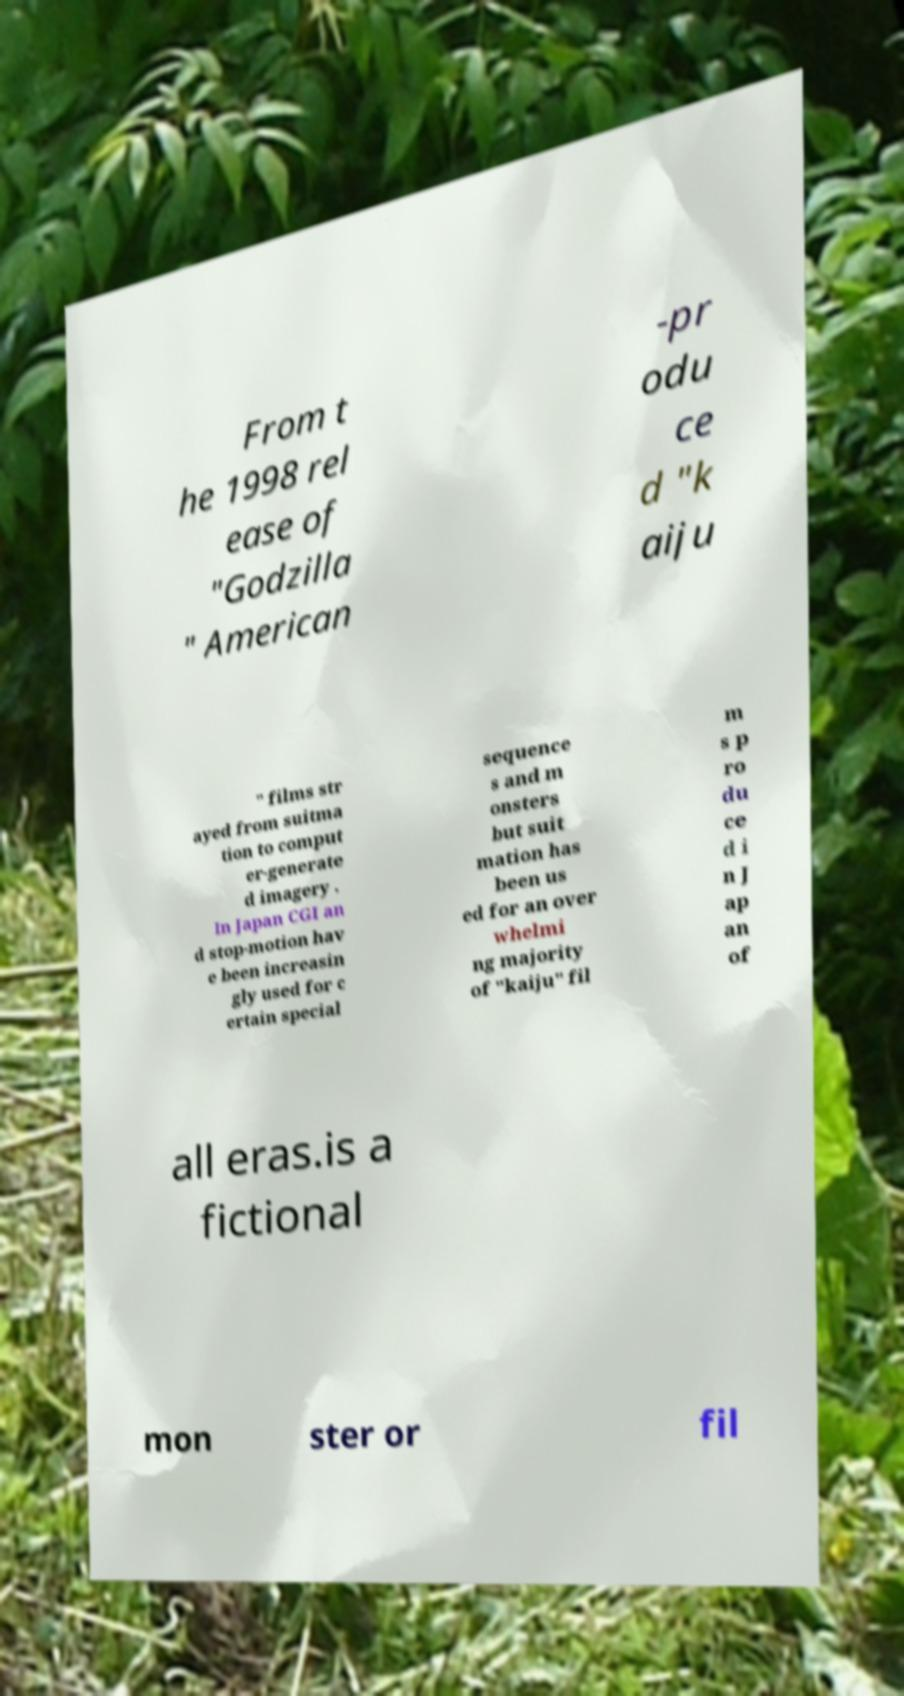Can you read and provide the text displayed in the image?This photo seems to have some interesting text. Can you extract and type it out for me? From t he 1998 rel ease of "Godzilla " American -pr odu ce d "k aiju " films str ayed from suitma tion to comput er-generate d imagery . In Japan CGI an d stop-motion hav e been increasin gly used for c ertain special sequence s and m onsters but suit mation has been us ed for an over whelmi ng majority of "kaiju" fil m s p ro du ce d i n J ap an of all eras.is a fictional mon ster or fil 